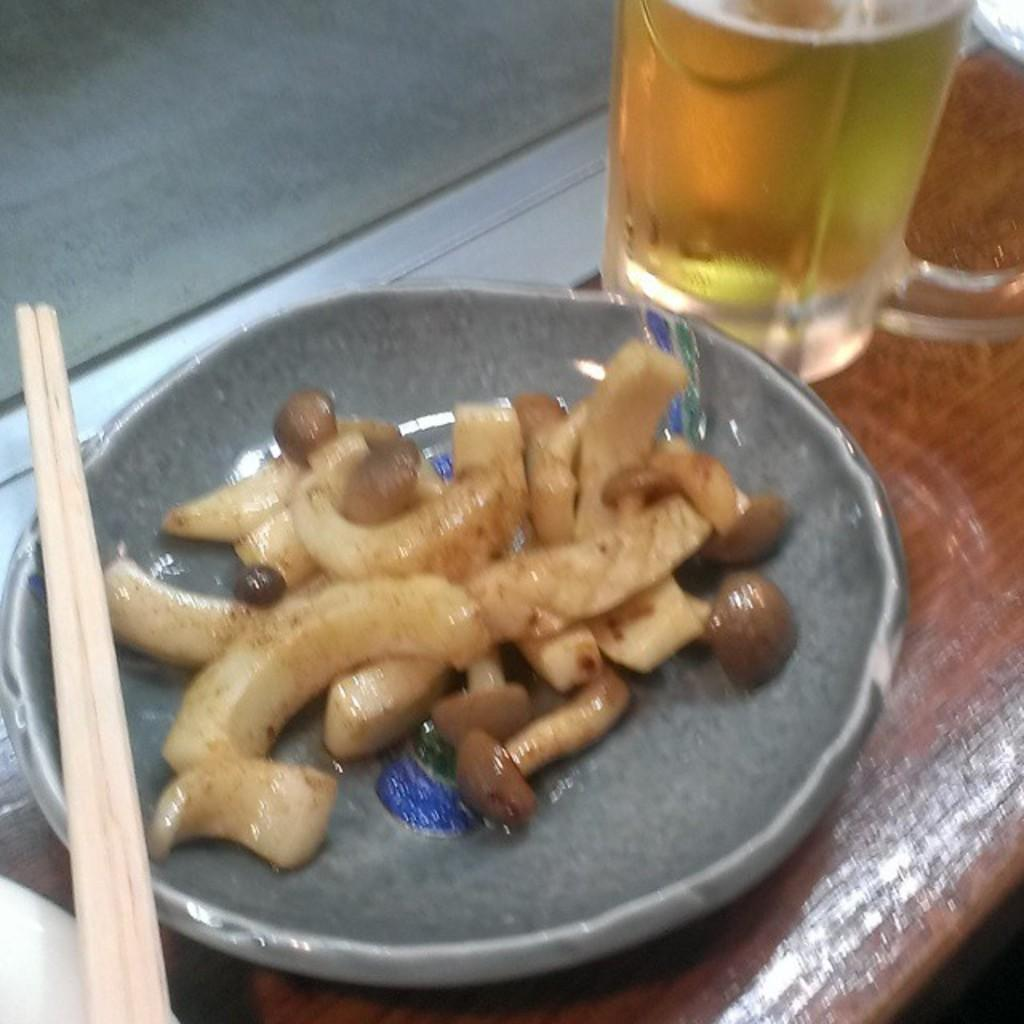What is on the plate that is visible in the image? There are food items in a plate in the image. Where is the plate located in the image? The plate is on a table in the image. What is the beverage container in the image? There is a beer mug in the image. What type of utensils or objects can be seen in the image? There are sticks in the image. What type of map is visible on the table in the image? A: There is no map present in the image; it features a plate of food items, a beer mug, and sticks. What organization is responsible for the food items in the image? There is no information about an organization responsible for the food items in the image. 